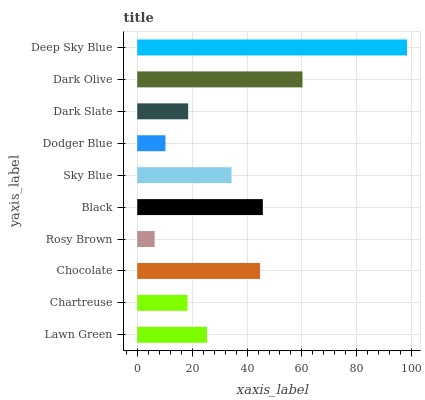Is Rosy Brown the minimum?
Answer yes or no. Yes. Is Deep Sky Blue the maximum?
Answer yes or no. Yes. Is Chartreuse the minimum?
Answer yes or no. No. Is Chartreuse the maximum?
Answer yes or no. No. Is Lawn Green greater than Chartreuse?
Answer yes or no. Yes. Is Chartreuse less than Lawn Green?
Answer yes or no. Yes. Is Chartreuse greater than Lawn Green?
Answer yes or no. No. Is Lawn Green less than Chartreuse?
Answer yes or no. No. Is Sky Blue the high median?
Answer yes or no. Yes. Is Lawn Green the low median?
Answer yes or no. Yes. Is Deep Sky Blue the high median?
Answer yes or no. No. Is Sky Blue the low median?
Answer yes or no. No. 